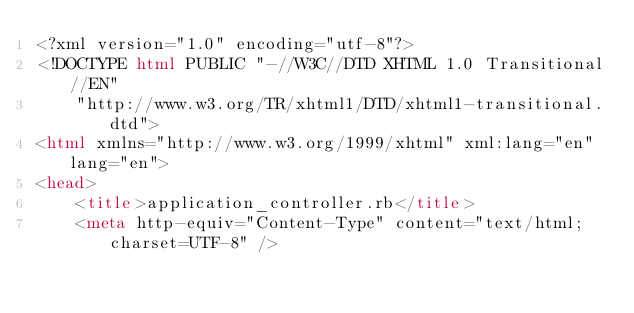Convert code to text. <code><loc_0><loc_0><loc_500><loc_500><_HTML_><?xml version="1.0" encoding="utf-8"?>
<!DOCTYPE html PUBLIC "-//W3C//DTD XHTML 1.0 Transitional//EN"
    "http://www.w3.org/TR/xhtml1/DTD/xhtml1-transitional.dtd">
<html xmlns="http://www.w3.org/1999/xhtml" xml:lang="en" lang="en">
<head>
    <title>application_controller.rb</title>
    <meta http-equiv="Content-Type" content="text/html; charset=UTF-8" /></code> 